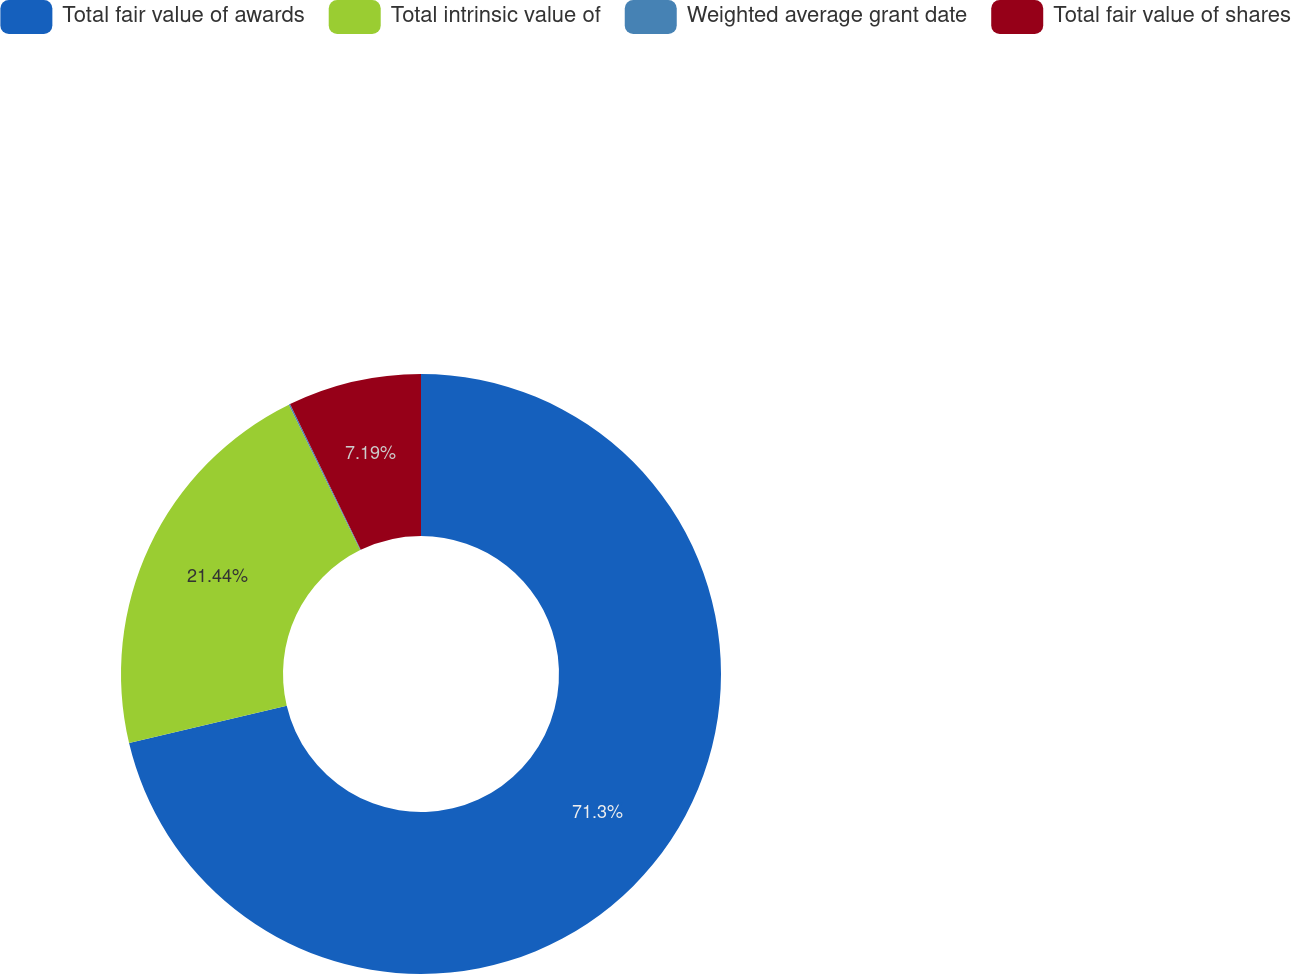Convert chart. <chart><loc_0><loc_0><loc_500><loc_500><pie_chart><fcel>Total fair value of awards<fcel>Total intrinsic value of<fcel>Weighted average grant date<fcel>Total fair value of shares<nl><fcel>71.3%<fcel>21.44%<fcel>0.07%<fcel>7.19%<nl></chart> 